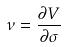<formula> <loc_0><loc_0><loc_500><loc_500>\nu = \frac { \partial V } { \partial \sigma }</formula> 